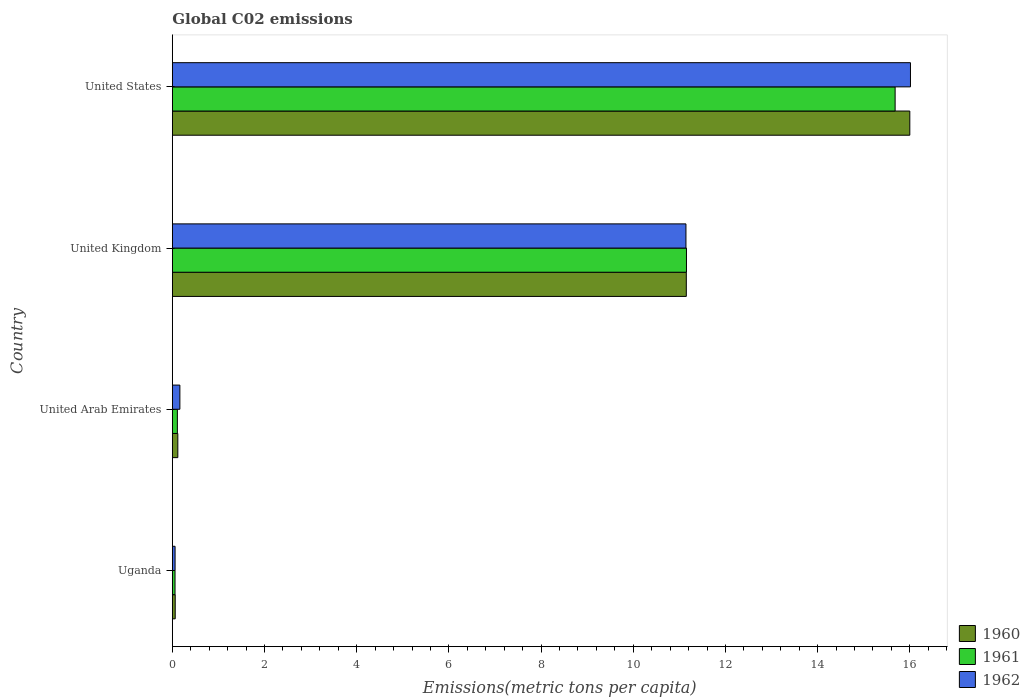How many different coloured bars are there?
Keep it short and to the point. 3. How many groups of bars are there?
Provide a succinct answer. 4. Are the number of bars per tick equal to the number of legend labels?
Provide a short and direct response. Yes. Are the number of bars on each tick of the Y-axis equal?
Offer a terse response. Yes. How many bars are there on the 2nd tick from the top?
Give a very brief answer. 3. In how many cases, is the number of bars for a given country not equal to the number of legend labels?
Your answer should be very brief. 0. What is the amount of CO2 emitted in in 1962 in United States?
Give a very brief answer. 16.01. Across all countries, what is the maximum amount of CO2 emitted in in 1960?
Your answer should be compact. 16. Across all countries, what is the minimum amount of CO2 emitted in in 1961?
Your response must be concise. 0.06. In which country was the amount of CO2 emitted in in 1960 maximum?
Make the answer very short. United States. In which country was the amount of CO2 emitted in in 1960 minimum?
Keep it short and to the point. Uganda. What is the total amount of CO2 emitted in in 1961 in the graph?
Provide a short and direct response. 27. What is the difference between the amount of CO2 emitted in in 1960 in United Kingdom and that in United States?
Offer a terse response. -4.85. What is the difference between the amount of CO2 emitted in in 1962 in United States and the amount of CO2 emitted in in 1961 in United Arab Emirates?
Make the answer very short. 15.91. What is the average amount of CO2 emitted in in 1962 per country?
Provide a short and direct response. 6.84. What is the difference between the amount of CO2 emitted in in 1961 and amount of CO2 emitted in in 1962 in United States?
Provide a short and direct response. -0.33. What is the ratio of the amount of CO2 emitted in in 1960 in United Arab Emirates to that in United Kingdom?
Make the answer very short. 0.01. Is the amount of CO2 emitted in in 1961 in United Arab Emirates less than that in United Kingdom?
Your answer should be very brief. Yes. What is the difference between the highest and the second highest amount of CO2 emitted in in 1960?
Provide a short and direct response. 4.85. What is the difference between the highest and the lowest amount of CO2 emitted in in 1961?
Your response must be concise. 15.62. In how many countries, is the amount of CO2 emitted in in 1960 greater than the average amount of CO2 emitted in in 1960 taken over all countries?
Keep it short and to the point. 2. What does the 1st bar from the top in United Kingdom represents?
Your answer should be very brief. 1962. What does the 3rd bar from the bottom in United States represents?
Your answer should be very brief. 1962. How many countries are there in the graph?
Your answer should be compact. 4. Does the graph contain any zero values?
Ensure brevity in your answer.  No. How many legend labels are there?
Your answer should be very brief. 3. How are the legend labels stacked?
Your answer should be very brief. Vertical. What is the title of the graph?
Your answer should be very brief. Global C02 emissions. What is the label or title of the X-axis?
Make the answer very short. Emissions(metric tons per capita). What is the Emissions(metric tons per capita) of 1960 in Uganda?
Give a very brief answer. 0.06. What is the Emissions(metric tons per capita) of 1961 in Uganda?
Provide a succinct answer. 0.06. What is the Emissions(metric tons per capita) in 1962 in Uganda?
Make the answer very short. 0.06. What is the Emissions(metric tons per capita) of 1960 in United Arab Emirates?
Provide a succinct answer. 0.12. What is the Emissions(metric tons per capita) of 1961 in United Arab Emirates?
Your response must be concise. 0.11. What is the Emissions(metric tons per capita) of 1962 in United Arab Emirates?
Give a very brief answer. 0.16. What is the Emissions(metric tons per capita) in 1960 in United Kingdom?
Offer a very short reply. 11.15. What is the Emissions(metric tons per capita) in 1961 in United Kingdom?
Provide a succinct answer. 11.15. What is the Emissions(metric tons per capita) of 1962 in United Kingdom?
Provide a short and direct response. 11.14. What is the Emissions(metric tons per capita) of 1960 in United States?
Make the answer very short. 16. What is the Emissions(metric tons per capita) of 1961 in United States?
Your answer should be very brief. 15.68. What is the Emissions(metric tons per capita) of 1962 in United States?
Offer a terse response. 16.01. Across all countries, what is the maximum Emissions(metric tons per capita) in 1960?
Offer a terse response. 16. Across all countries, what is the maximum Emissions(metric tons per capita) in 1961?
Offer a terse response. 15.68. Across all countries, what is the maximum Emissions(metric tons per capita) in 1962?
Your answer should be very brief. 16.01. Across all countries, what is the minimum Emissions(metric tons per capita) in 1960?
Keep it short and to the point. 0.06. Across all countries, what is the minimum Emissions(metric tons per capita) of 1961?
Offer a very short reply. 0.06. Across all countries, what is the minimum Emissions(metric tons per capita) in 1962?
Provide a short and direct response. 0.06. What is the total Emissions(metric tons per capita) of 1960 in the graph?
Provide a short and direct response. 27.33. What is the total Emissions(metric tons per capita) of 1961 in the graph?
Your response must be concise. 27. What is the total Emissions(metric tons per capita) in 1962 in the graph?
Your response must be concise. 27.38. What is the difference between the Emissions(metric tons per capita) in 1960 in Uganda and that in United Arab Emirates?
Give a very brief answer. -0.06. What is the difference between the Emissions(metric tons per capita) in 1961 in Uganda and that in United Arab Emirates?
Your answer should be compact. -0.05. What is the difference between the Emissions(metric tons per capita) in 1962 in Uganda and that in United Arab Emirates?
Offer a very short reply. -0.1. What is the difference between the Emissions(metric tons per capita) in 1960 in Uganda and that in United Kingdom?
Your response must be concise. -11.09. What is the difference between the Emissions(metric tons per capita) of 1961 in Uganda and that in United Kingdom?
Provide a succinct answer. -11.1. What is the difference between the Emissions(metric tons per capita) in 1962 in Uganda and that in United Kingdom?
Make the answer very short. -11.08. What is the difference between the Emissions(metric tons per capita) of 1960 in Uganda and that in United States?
Give a very brief answer. -15.94. What is the difference between the Emissions(metric tons per capita) of 1961 in Uganda and that in United States?
Keep it short and to the point. -15.62. What is the difference between the Emissions(metric tons per capita) in 1962 in Uganda and that in United States?
Your response must be concise. -15.95. What is the difference between the Emissions(metric tons per capita) in 1960 in United Arab Emirates and that in United Kingdom?
Provide a succinct answer. -11.03. What is the difference between the Emissions(metric tons per capita) in 1961 in United Arab Emirates and that in United Kingdom?
Your answer should be compact. -11.05. What is the difference between the Emissions(metric tons per capita) in 1962 in United Arab Emirates and that in United Kingdom?
Make the answer very short. -10.98. What is the difference between the Emissions(metric tons per capita) of 1960 in United Arab Emirates and that in United States?
Offer a terse response. -15.88. What is the difference between the Emissions(metric tons per capita) in 1961 in United Arab Emirates and that in United States?
Provide a succinct answer. -15.57. What is the difference between the Emissions(metric tons per capita) in 1962 in United Arab Emirates and that in United States?
Provide a short and direct response. -15.85. What is the difference between the Emissions(metric tons per capita) of 1960 in United Kingdom and that in United States?
Offer a terse response. -4.85. What is the difference between the Emissions(metric tons per capita) in 1961 in United Kingdom and that in United States?
Your response must be concise. -4.53. What is the difference between the Emissions(metric tons per capita) in 1962 in United Kingdom and that in United States?
Your answer should be compact. -4.87. What is the difference between the Emissions(metric tons per capita) in 1960 in Uganda and the Emissions(metric tons per capita) in 1961 in United Arab Emirates?
Provide a succinct answer. -0.05. What is the difference between the Emissions(metric tons per capita) in 1960 in Uganda and the Emissions(metric tons per capita) in 1962 in United Arab Emirates?
Keep it short and to the point. -0.1. What is the difference between the Emissions(metric tons per capita) of 1961 in Uganda and the Emissions(metric tons per capita) of 1962 in United Arab Emirates?
Your response must be concise. -0.11. What is the difference between the Emissions(metric tons per capita) of 1960 in Uganda and the Emissions(metric tons per capita) of 1961 in United Kingdom?
Your answer should be compact. -11.09. What is the difference between the Emissions(metric tons per capita) in 1960 in Uganda and the Emissions(metric tons per capita) in 1962 in United Kingdom?
Provide a short and direct response. -11.08. What is the difference between the Emissions(metric tons per capita) in 1961 in Uganda and the Emissions(metric tons per capita) in 1962 in United Kingdom?
Your response must be concise. -11.08. What is the difference between the Emissions(metric tons per capita) of 1960 in Uganda and the Emissions(metric tons per capita) of 1961 in United States?
Give a very brief answer. -15.62. What is the difference between the Emissions(metric tons per capita) in 1960 in Uganda and the Emissions(metric tons per capita) in 1962 in United States?
Make the answer very short. -15.95. What is the difference between the Emissions(metric tons per capita) of 1961 in Uganda and the Emissions(metric tons per capita) of 1962 in United States?
Keep it short and to the point. -15.96. What is the difference between the Emissions(metric tons per capita) of 1960 in United Arab Emirates and the Emissions(metric tons per capita) of 1961 in United Kingdom?
Give a very brief answer. -11.04. What is the difference between the Emissions(metric tons per capita) in 1960 in United Arab Emirates and the Emissions(metric tons per capita) in 1962 in United Kingdom?
Your response must be concise. -11.02. What is the difference between the Emissions(metric tons per capita) of 1961 in United Arab Emirates and the Emissions(metric tons per capita) of 1962 in United Kingdom?
Offer a terse response. -11.03. What is the difference between the Emissions(metric tons per capita) of 1960 in United Arab Emirates and the Emissions(metric tons per capita) of 1961 in United States?
Give a very brief answer. -15.56. What is the difference between the Emissions(metric tons per capita) of 1960 in United Arab Emirates and the Emissions(metric tons per capita) of 1962 in United States?
Your response must be concise. -15.9. What is the difference between the Emissions(metric tons per capita) in 1961 in United Arab Emirates and the Emissions(metric tons per capita) in 1962 in United States?
Give a very brief answer. -15.9. What is the difference between the Emissions(metric tons per capita) in 1960 in United Kingdom and the Emissions(metric tons per capita) in 1961 in United States?
Ensure brevity in your answer.  -4.53. What is the difference between the Emissions(metric tons per capita) of 1960 in United Kingdom and the Emissions(metric tons per capita) of 1962 in United States?
Offer a very short reply. -4.86. What is the difference between the Emissions(metric tons per capita) in 1961 in United Kingdom and the Emissions(metric tons per capita) in 1962 in United States?
Offer a very short reply. -4.86. What is the average Emissions(metric tons per capita) of 1960 per country?
Your answer should be very brief. 6.83. What is the average Emissions(metric tons per capita) of 1961 per country?
Your answer should be compact. 6.75. What is the average Emissions(metric tons per capita) of 1962 per country?
Give a very brief answer. 6.84. What is the difference between the Emissions(metric tons per capita) of 1960 and Emissions(metric tons per capita) of 1961 in Uganda?
Your response must be concise. 0. What is the difference between the Emissions(metric tons per capita) of 1960 and Emissions(metric tons per capita) of 1962 in Uganda?
Provide a short and direct response. 0. What is the difference between the Emissions(metric tons per capita) in 1961 and Emissions(metric tons per capita) in 1962 in Uganda?
Your response must be concise. -0. What is the difference between the Emissions(metric tons per capita) in 1960 and Emissions(metric tons per capita) in 1961 in United Arab Emirates?
Keep it short and to the point. 0.01. What is the difference between the Emissions(metric tons per capita) in 1960 and Emissions(metric tons per capita) in 1962 in United Arab Emirates?
Offer a terse response. -0.04. What is the difference between the Emissions(metric tons per capita) of 1961 and Emissions(metric tons per capita) of 1962 in United Arab Emirates?
Offer a very short reply. -0.05. What is the difference between the Emissions(metric tons per capita) of 1960 and Emissions(metric tons per capita) of 1961 in United Kingdom?
Your response must be concise. -0. What is the difference between the Emissions(metric tons per capita) in 1960 and Emissions(metric tons per capita) in 1962 in United Kingdom?
Your answer should be very brief. 0.01. What is the difference between the Emissions(metric tons per capita) of 1961 and Emissions(metric tons per capita) of 1962 in United Kingdom?
Give a very brief answer. 0.01. What is the difference between the Emissions(metric tons per capita) in 1960 and Emissions(metric tons per capita) in 1961 in United States?
Make the answer very short. 0.32. What is the difference between the Emissions(metric tons per capita) of 1960 and Emissions(metric tons per capita) of 1962 in United States?
Your answer should be compact. -0.01. What is the difference between the Emissions(metric tons per capita) in 1961 and Emissions(metric tons per capita) in 1962 in United States?
Give a very brief answer. -0.33. What is the ratio of the Emissions(metric tons per capita) in 1960 in Uganda to that in United Arab Emirates?
Offer a terse response. 0.52. What is the ratio of the Emissions(metric tons per capita) of 1961 in Uganda to that in United Arab Emirates?
Ensure brevity in your answer.  0.53. What is the ratio of the Emissions(metric tons per capita) in 1962 in Uganda to that in United Arab Emirates?
Your answer should be very brief. 0.36. What is the ratio of the Emissions(metric tons per capita) of 1960 in Uganda to that in United Kingdom?
Ensure brevity in your answer.  0.01. What is the ratio of the Emissions(metric tons per capita) in 1961 in Uganda to that in United Kingdom?
Offer a very short reply. 0.01. What is the ratio of the Emissions(metric tons per capita) in 1962 in Uganda to that in United Kingdom?
Offer a very short reply. 0.01. What is the ratio of the Emissions(metric tons per capita) of 1960 in Uganda to that in United States?
Ensure brevity in your answer.  0. What is the ratio of the Emissions(metric tons per capita) of 1961 in Uganda to that in United States?
Make the answer very short. 0. What is the ratio of the Emissions(metric tons per capita) in 1962 in Uganda to that in United States?
Keep it short and to the point. 0. What is the ratio of the Emissions(metric tons per capita) in 1960 in United Arab Emirates to that in United Kingdom?
Keep it short and to the point. 0.01. What is the ratio of the Emissions(metric tons per capita) in 1961 in United Arab Emirates to that in United Kingdom?
Your answer should be compact. 0.01. What is the ratio of the Emissions(metric tons per capita) of 1962 in United Arab Emirates to that in United Kingdom?
Keep it short and to the point. 0.01. What is the ratio of the Emissions(metric tons per capita) in 1960 in United Arab Emirates to that in United States?
Your answer should be very brief. 0.01. What is the ratio of the Emissions(metric tons per capita) of 1961 in United Arab Emirates to that in United States?
Provide a succinct answer. 0.01. What is the ratio of the Emissions(metric tons per capita) in 1962 in United Arab Emirates to that in United States?
Give a very brief answer. 0.01. What is the ratio of the Emissions(metric tons per capita) in 1960 in United Kingdom to that in United States?
Your answer should be very brief. 0.7. What is the ratio of the Emissions(metric tons per capita) of 1961 in United Kingdom to that in United States?
Keep it short and to the point. 0.71. What is the ratio of the Emissions(metric tons per capita) of 1962 in United Kingdom to that in United States?
Provide a short and direct response. 0.7. What is the difference between the highest and the second highest Emissions(metric tons per capita) in 1960?
Provide a succinct answer. 4.85. What is the difference between the highest and the second highest Emissions(metric tons per capita) in 1961?
Offer a very short reply. 4.53. What is the difference between the highest and the second highest Emissions(metric tons per capita) in 1962?
Ensure brevity in your answer.  4.87. What is the difference between the highest and the lowest Emissions(metric tons per capita) of 1960?
Keep it short and to the point. 15.94. What is the difference between the highest and the lowest Emissions(metric tons per capita) of 1961?
Ensure brevity in your answer.  15.62. What is the difference between the highest and the lowest Emissions(metric tons per capita) of 1962?
Your response must be concise. 15.95. 